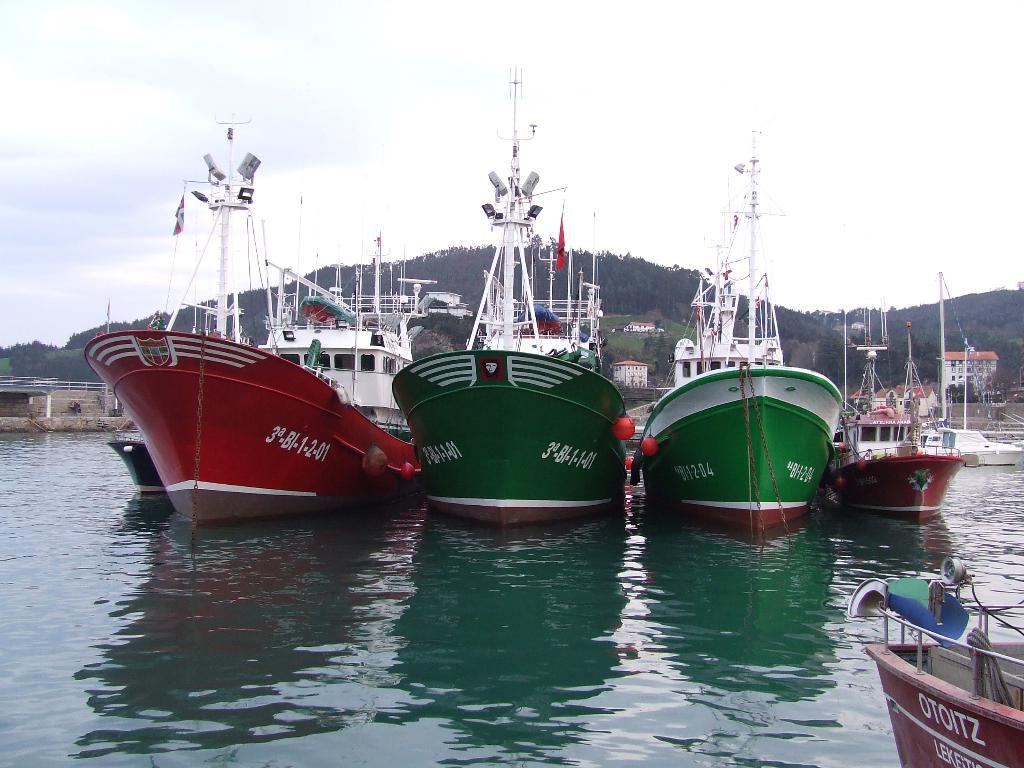What type of vehicles are in the image? There are ships in the image. Where are the ships located? The ships are on the water surface. What can be seen in the background of the image? There are mountains visible in the background of the image. What type of comb can be seen in the image? There is no comb present in the image; it features ships on the water surface with mountains in the background. 